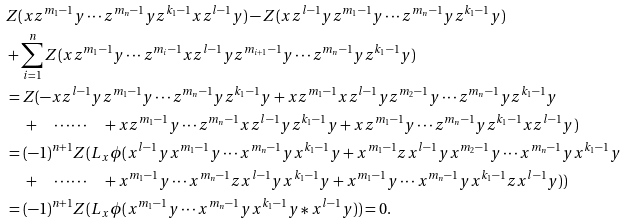<formula> <loc_0><loc_0><loc_500><loc_500>& Z ( x z ^ { m _ { 1 } - 1 } y \cdots z ^ { m _ { n } - 1 } y z ^ { k _ { 1 } - 1 } x z ^ { l - 1 } y ) - Z ( x z ^ { l - 1 } y z ^ { m _ { 1 } - 1 } y \cdots z ^ { m _ { n } - 1 } y z ^ { k _ { 1 } - 1 } y ) \\ & + \sum _ { i = 1 } ^ { n } Z ( x z ^ { m _ { 1 } - 1 } y \cdots z ^ { m _ { i } - 1 } x z ^ { l - 1 } y z ^ { m _ { i + 1 } - 1 } y \cdots z ^ { m _ { n } - 1 } y z ^ { k _ { 1 } - 1 } y ) \\ & = Z ( - x z ^ { l - 1 } y z ^ { m _ { 1 } - 1 } y \cdots z ^ { m _ { n } - 1 } y z ^ { k _ { 1 } - 1 } y + x z ^ { m _ { 1 } - 1 } x z ^ { l - 1 } y z ^ { m _ { 2 } - 1 } y \cdots z ^ { m _ { n } - 1 } y z ^ { k _ { 1 } - 1 } y \\ & \quad \, + \quad \cdots \cdots \quad + x z ^ { m _ { 1 } - 1 } y \cdots z ^ { m _ { n } - 1 } x z ^ { l - 1 } y z ^ { k _ { 1 } - 1 } y + x z ^ { m _ { 1 } - 1 } y \cdots z ^ { m _ { n } - 1 } y z ^ { k _ { 1 } - 1 } x z ^ { l - 1 } y ) \\ & = ( - 1 ) ^ { n + 1 } Z ( L _ { x } \phi ( x ^ { l - 1 } y x ^ { m _ { 1 } - 1 } y \cdots x ^ { m _ { n } - 1 } y x ^ { k _ { 1 } - 1 } y + x ^ { m _ { 1 } - 1 } z x ^ { l - 1 } y x ^ { m _ { 2 } - 1 } y \cdots x ^ { m _ { n } - 1 } y x ^ { k _ { 1 } - 1 } y \\ & \quad \, + \quad \cdots \cdots \quad + x ^ { m _ { 1 } - 1 } y \cdots x ^ { m _ { n } - 1 } z x ^ { l - 1 } y x ^ { k _ { 1 } - 1 } y + x ^ { m _ { 1 } - 1 } y \cdots x ^ { m _ { n } - 1 } y x ^ { k _ { 1 } - 1 } z x ^ { l - 1 } y ) ) \\ & = ( - 1 ) ^ { n + 1 } Z ( L _ { x } \phi ( x ^ { m _ { 1 } - 1 } y \cdots x ^ { m _ { n } - 1 } y x ^ { k _ { 1 } - 1 } y \ast x ^ { l - 1 } y ) ) = 0 .</formula> 